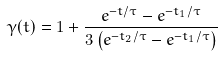Convert formula to latex. <formula><loc_0><loc_0><loc_500><loc_500>\gamma ( t ) = 1 + \frac { e ^ { - t / \tau } - e ^ { - t _ { 1 } / \tau } } { 3 \left ( e ^ { - t _ { 2 } / \tau } - e ^ { - t _ { 1 } / \tau } \right ) }</formula> 